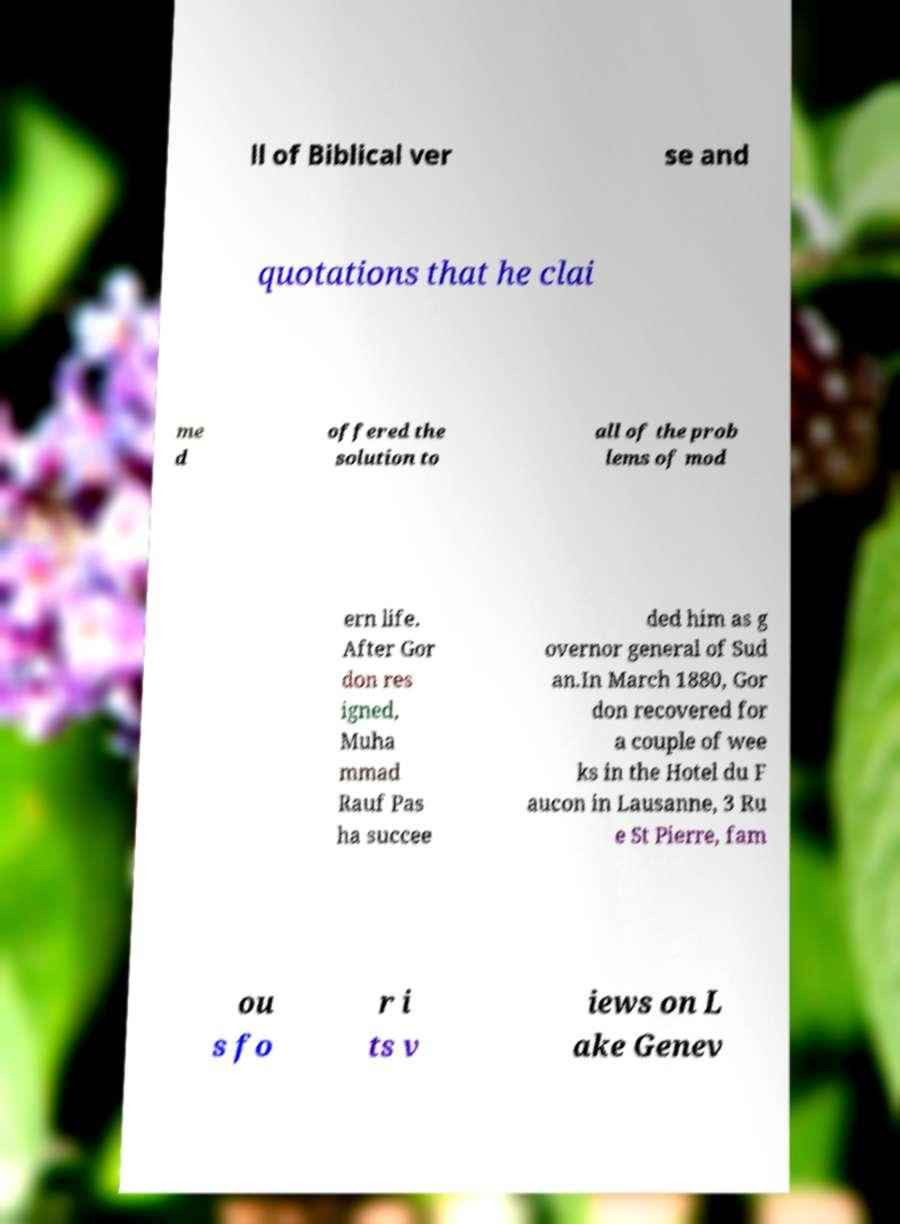There's text embedded in this image that I need extracted. Can you transcribe it verbatim? ll of Biblical ver se and quotations that he clai me d offered the solution to all of the prob lems of mod ern life. After Gor don res igned, Muha mmad Rauf Pas ha succee ded him as g overnor general of Sud an.In March 1880, Gor don recovered for a couple of wee ks in the Hotel du F aucon in Lausanne, 3 Ru e St Pierre, fam ou s fo r i ts v iews on L ake Genev 